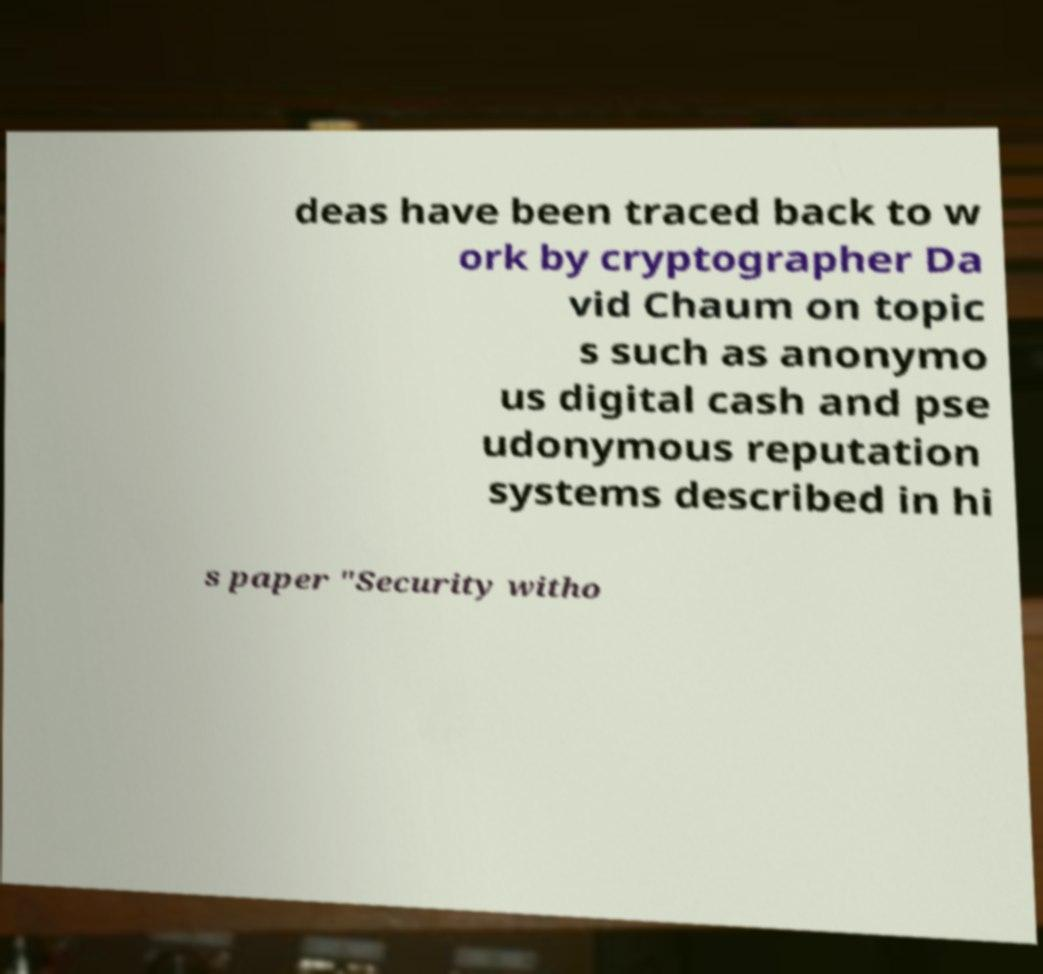Can you read and provide the text displayed in the image?This photo seems to have some interesting text. Can you extract and type it out for me? deas have been traced back to w ork by cryptographer Da vid Chaum on topic s such as anonymo us digital cash and pse udonymous reputation systems described in hi s paper "Security witho 